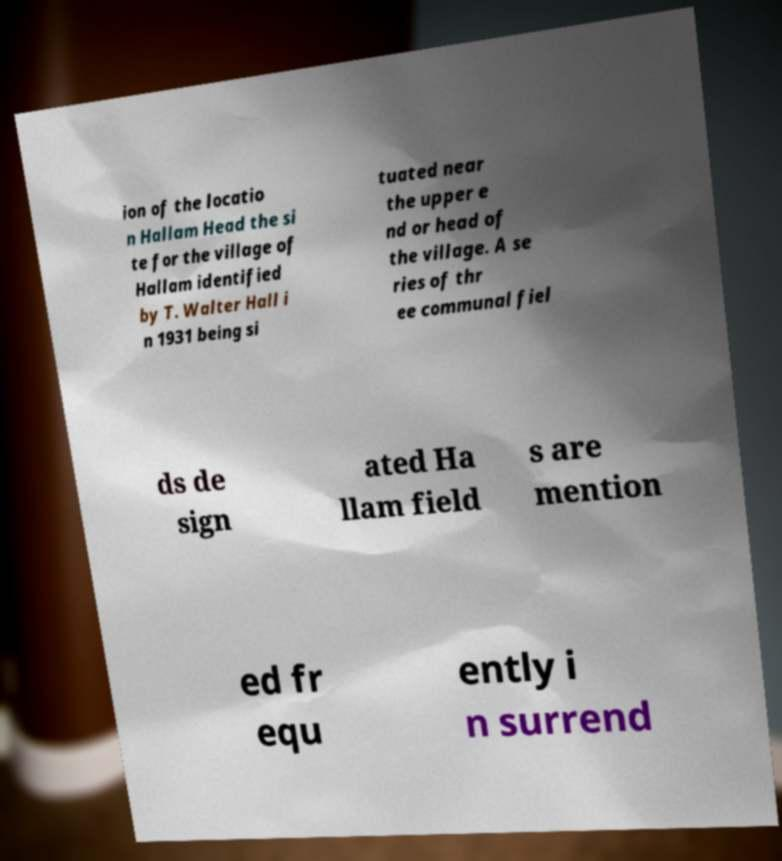Please read and relay the text visible in this image. What does it say? ion of the locatio n Hallam Head the si te for the village of Hallam identified by T. Walter Hall i n 1931 being si tuated near the upper e nd or head of the village. A se ries of thr ee communal fiel ds de sign ated Ha llam field s are mention ed fr equ ently i n surrend 